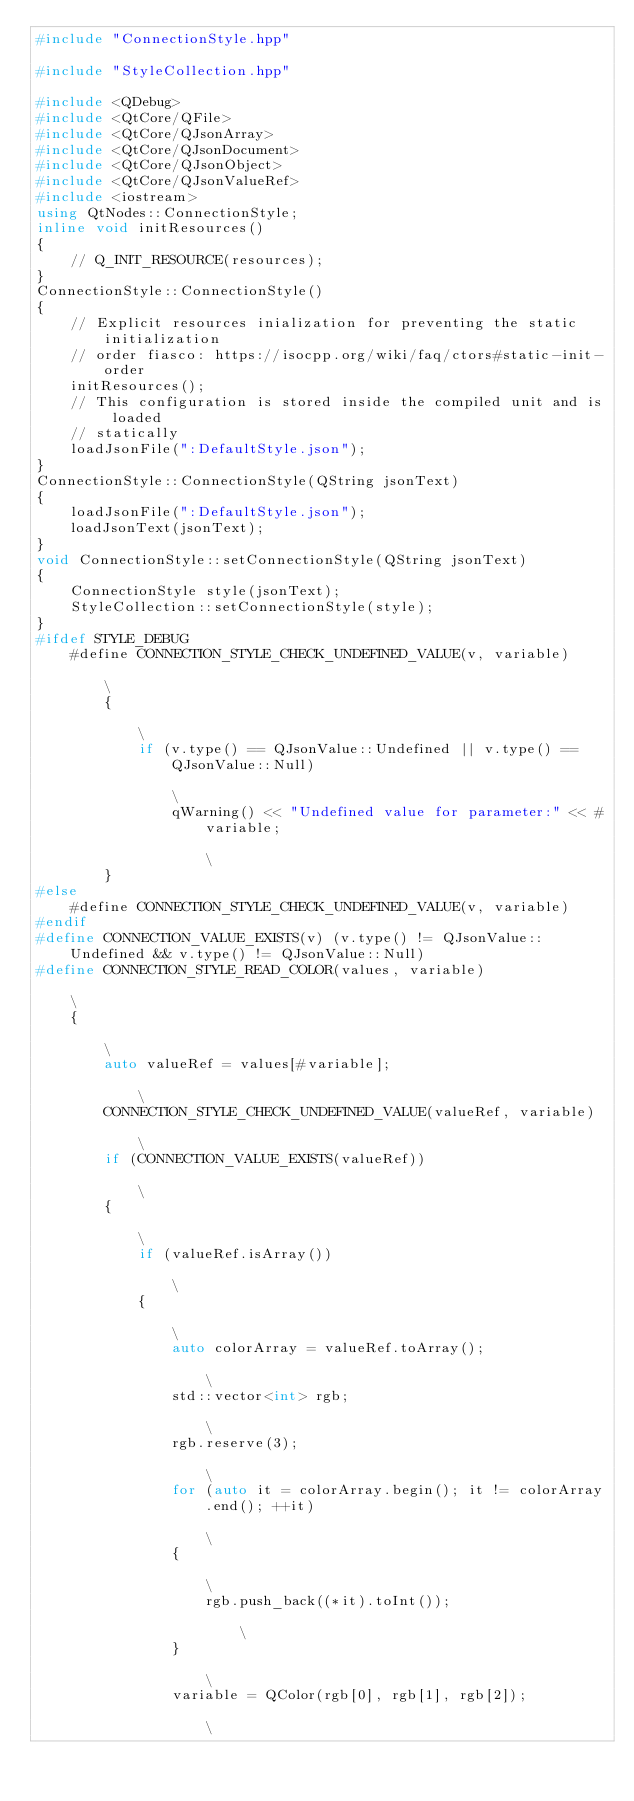<code> <loc_0><loc_0><loc_500><loc_500><_C++_>#include "ConnectionStyle.hpp"

#include "StyleCollection.hpp"

#include <QDebug>
#include <QtCore/QFile>
#include <QtCore/QJsonArray>
#include <QtCore/QJsonDocument>
#include <QtCore/QJsonObject>
#include <QtCore/QJsonValueRef>
#include <iostream>
using QtNodes::ConnectionStyle;
inline void initResources()
{
    // Q_INIT_RESOURCE(resources);
}
ConnectionStyle::ConnectionStyle()
{
    // Explicit resources inialization for preventing the static initialization
    // order fiasco: https://isocpp.org/wiki/faq/ctors#static-init-order
    initResources();
    // This configuration is stored inside the compiled unit and is loaded
    // statically
    loadJsonFile(":DefaultStyle.json");
}
ConnectionStyle::ConnectionStyle(QString jsonText)
{
    loadJsonFile(":DefaultStyle.json");
    loadJsonText(jsonText);
}
void ConnectionStyle::setConnectionStyle(QString jsonText)
{
    ConnectionStyle style(jsonText);
    StyleCollection::setConnectionStyle(style);
}
#ifdef STYLE_DEBUG
    #define CONNECTION_STYLE_CHECK_UNDEFINED_VALUE(v, variable)                                                                                 \
        {                                                                                                                                       \
            if (v.type() == QJsonValue::Undefined || v.type() == QJsonValue::Null)                                                              \
                qWarning() << "Undefined value for parameter:" << #variable;                                                                    \
        }
#else
    #define CONNECTION_STYLE_CHECK_UNDEFINED_VALUE(v, variable)
#endif
#define CONNECTION_VALUE_EXISTS(v) (v.type() != QJsonValue::Undefined && v.type() != QJsonValue::Null)
#define CONNECTION_STYLE_READ_COLOR(values, variable)                                                                                           \
    {                                                                                                                                           \
        auto valueRef = values[#variable];                                                                                                      \
        CONNECTION_STYLE_CHECK_UNDEFINED_VALUE(valueRef, variable)                                                                              \
        if (CONNECTION_VALUE_EXISTS(valueRef))                                                                                                  \
        {                                                                                                                                       \
            if (valueRef.isArray())                                                                                                             \
            {                                                                                                                                   \
                auto colorArray = valueRef.toArray();                                                                                           \
                std::vector<int> rgb;                                                                                                           \
                rgb.reserve(3);                                                                                                                 \
                for (auto it = colorArray.begin(); it != colorArray.end(); ++it)                                                                \
                {                                                                                                                               \
                    rgb.push_back((*it).toInt());                                                                                               \
                }                                                                                                                               \
                variable = QColor(rgb[0], rgb[1], rgb[2]);                                                                                      \</code> 